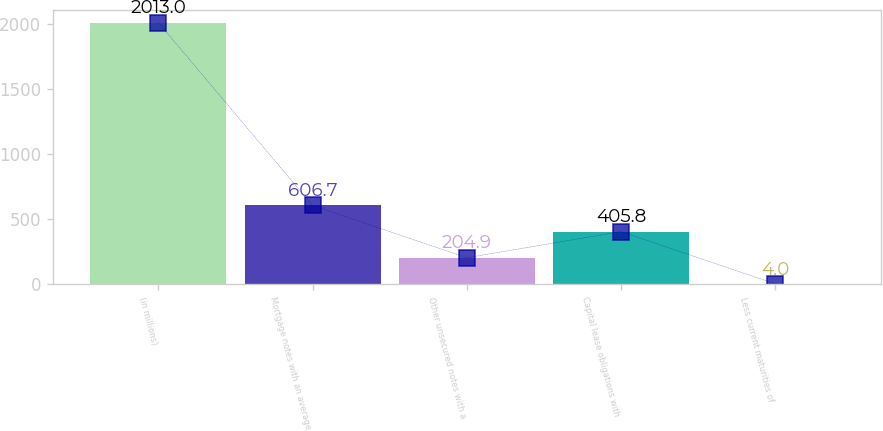<chart> <loc_0><loc_0><loc_500><loc_500><bar_chart><fcel>(in millions)<fcel>Mortgage notes with an average<fcel>Other unsecured notes with a<fcel>Capital lease obligations with<fcel>Less current maturities of<nl><fcel>2013<fcel>606.7<fcel>204.9<fcel>405.8<fcel>4<nl></chart> 